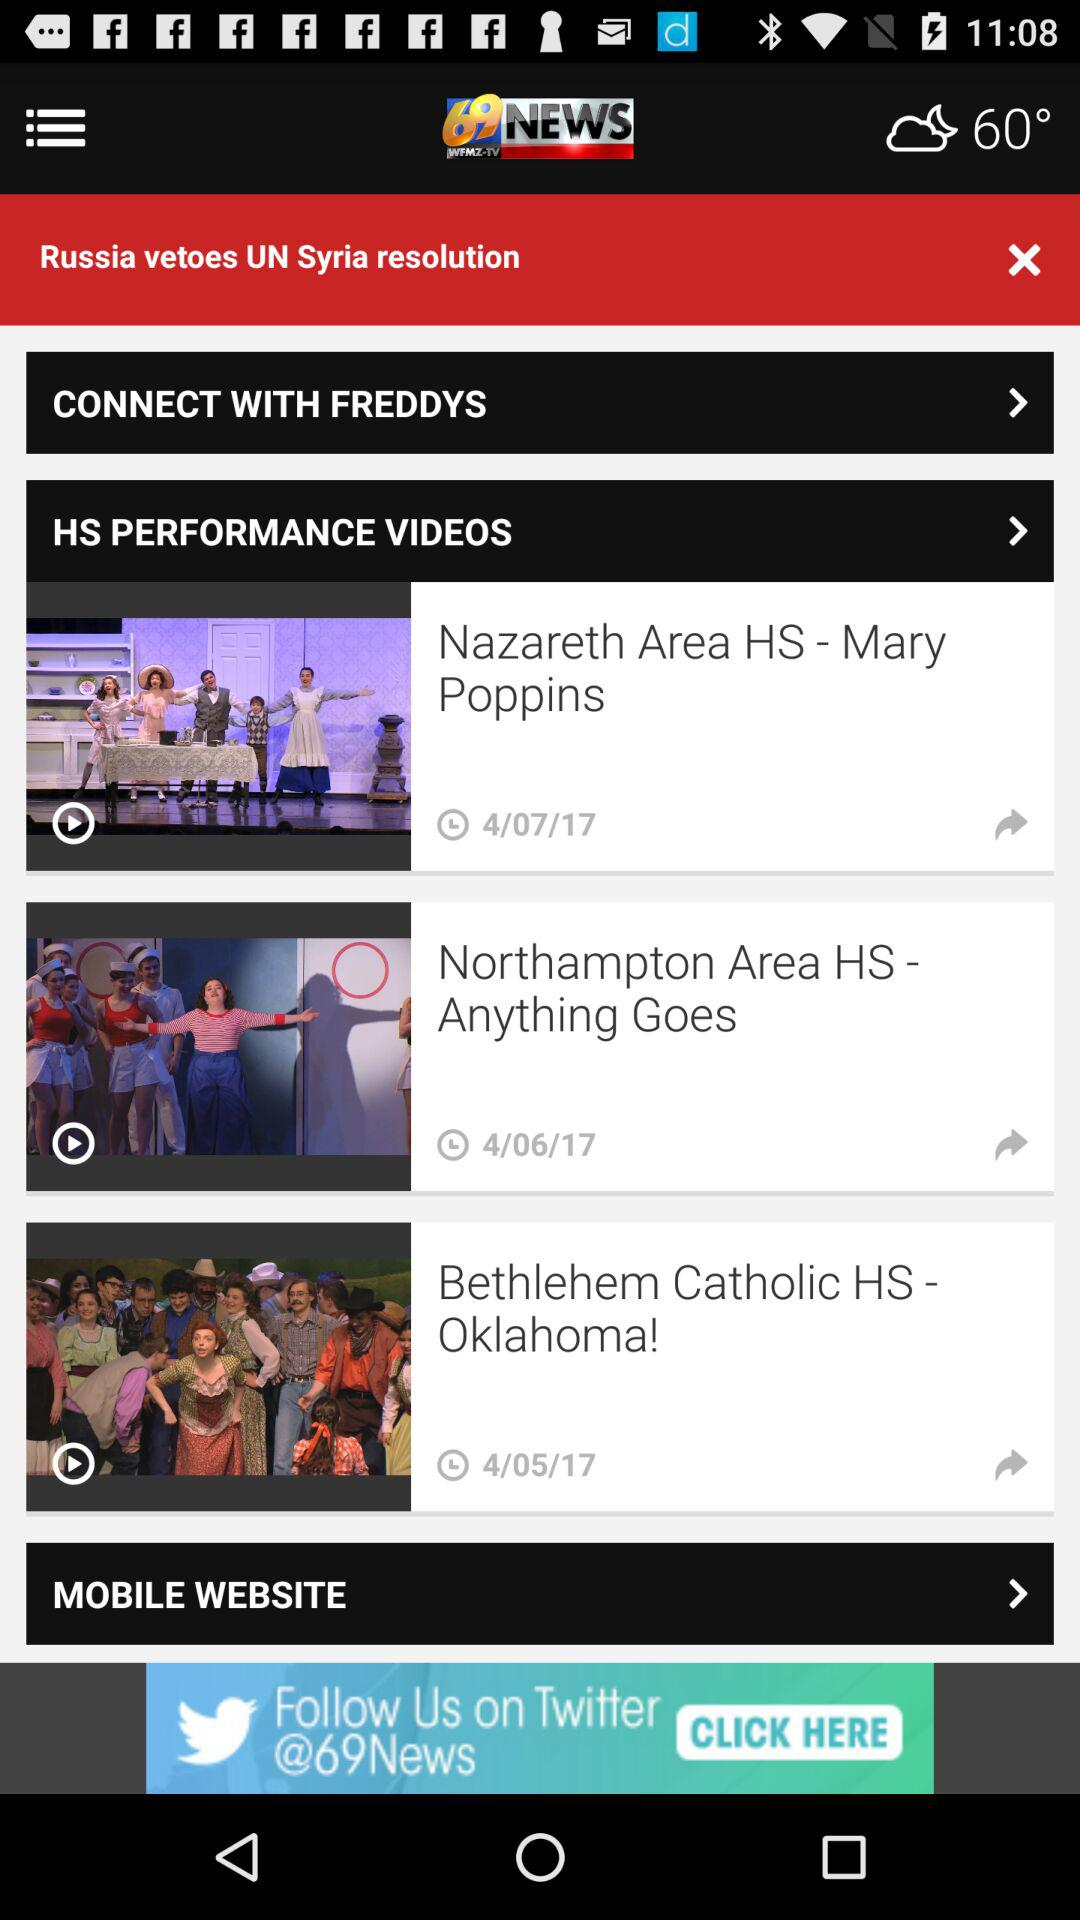What is the publication date of "Nazareth Area HS - Mary Poppins"? The publication date is April 7, 2017. 